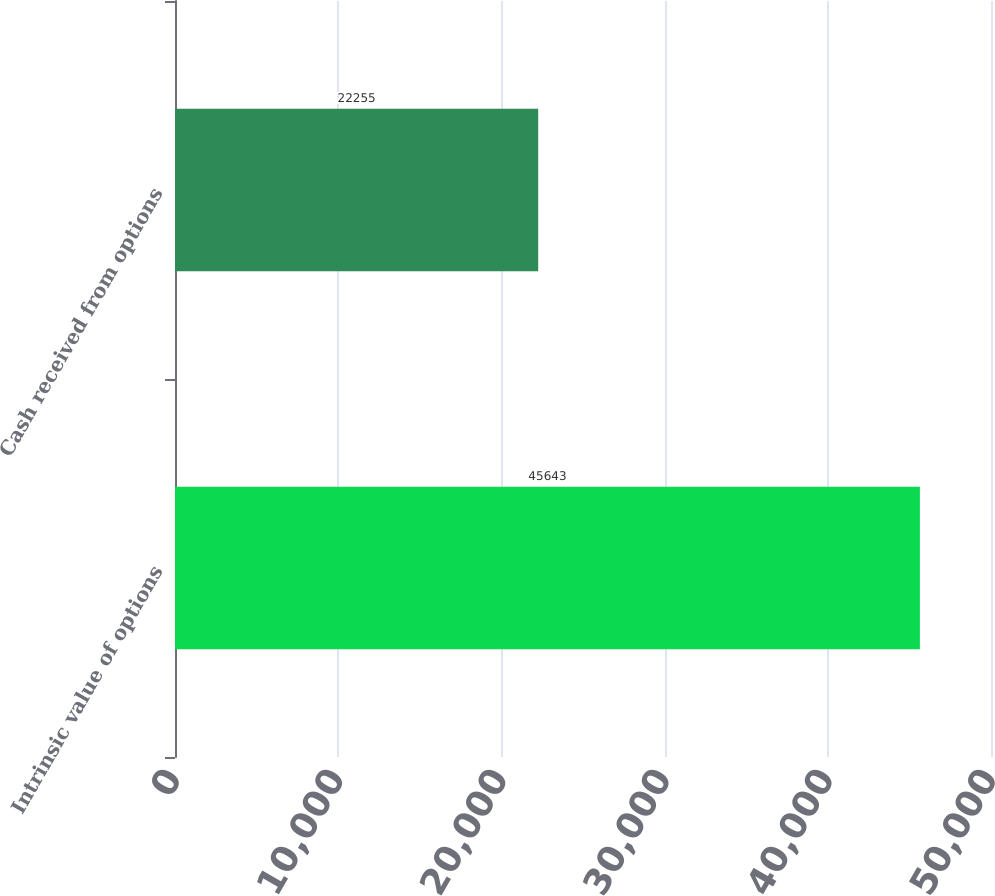Convert chart. <chart><loc_0><loc_0><loc_500><loc_500><bar_chart><fcel>Intrinsic value of options<fcel>Cash received from options<nl><fcel>45643<fcel>22255<nl></chart> 